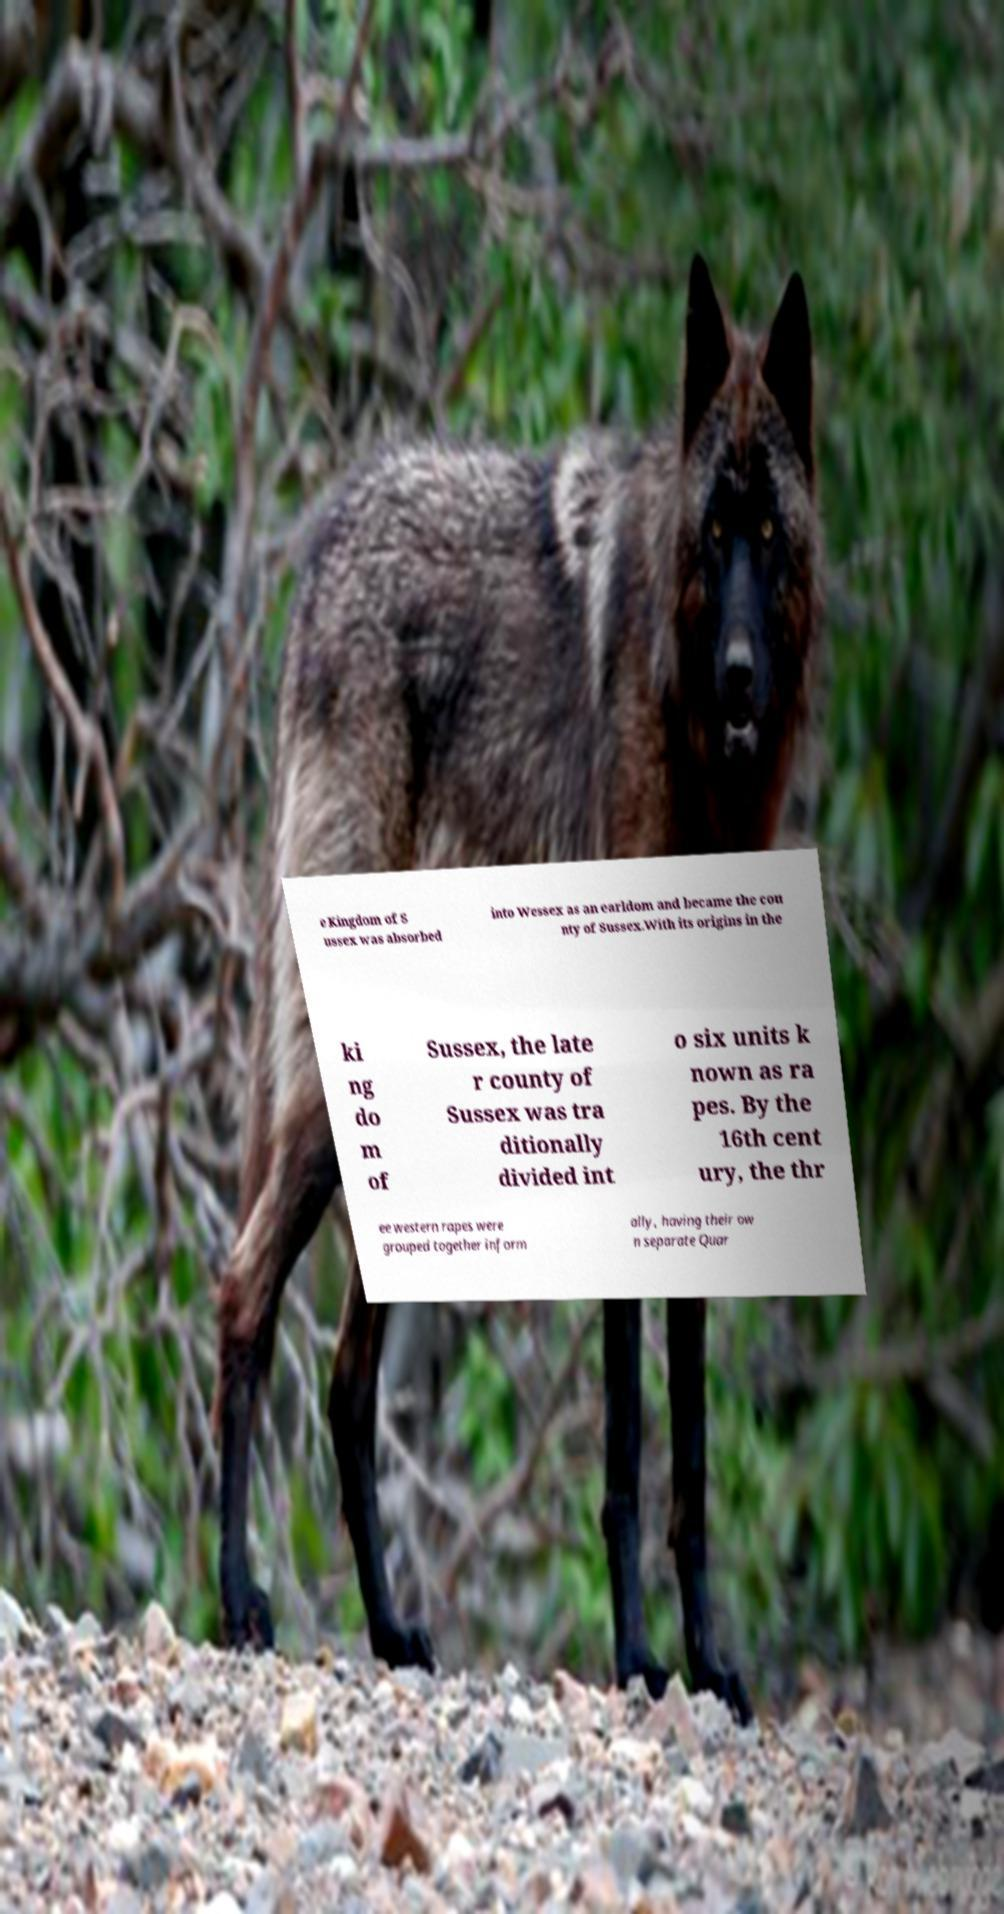I need the written content from this picture converted into text. Can you do that? e Kingdom of S ussex was absorbed into Wessex as an earldom and became the cou nty of Sussex.With its origins in the ki ng do m of Sussex, the late r county of Sussex was tra ditionally divided int o six units k nown as ra pes. By the 16th cent ury, the thr ee western rapes were grouped together inform ally, having their ow n separate Quar 